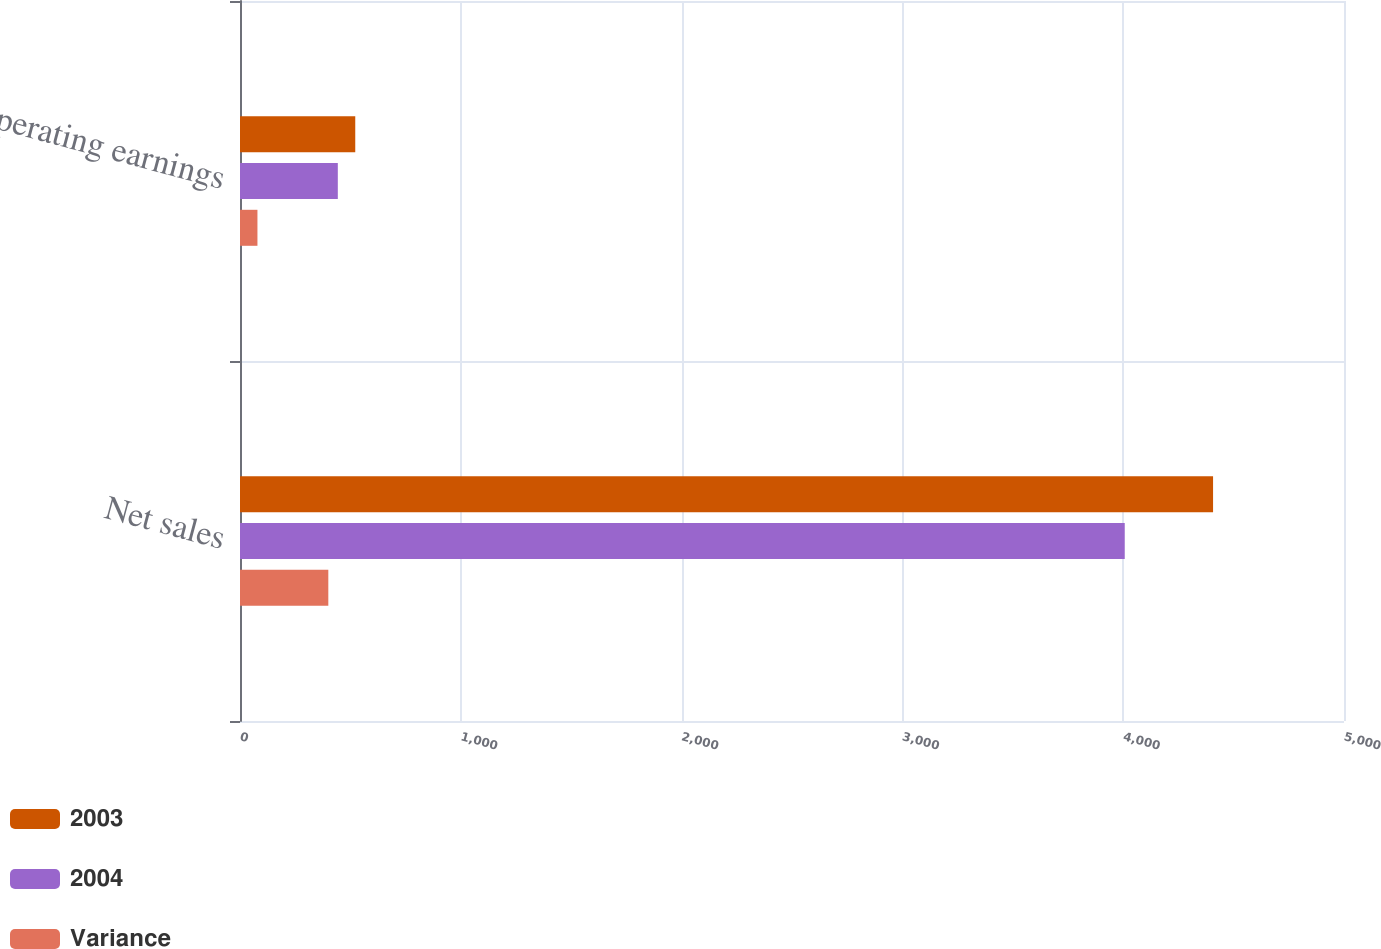<chart> <loc_0><loc_0><loc_500><loc_500><stacked_bar_chart><ecel><fcel>Net sales<fcel>Operating earnings<nl><fcel>2003<fcel>4407<fcel>522<nl><fcel>2004<fcel>4007<fcel>443<nl><fcel>Variance<fcel>400<fcel>79<nl></chart> 